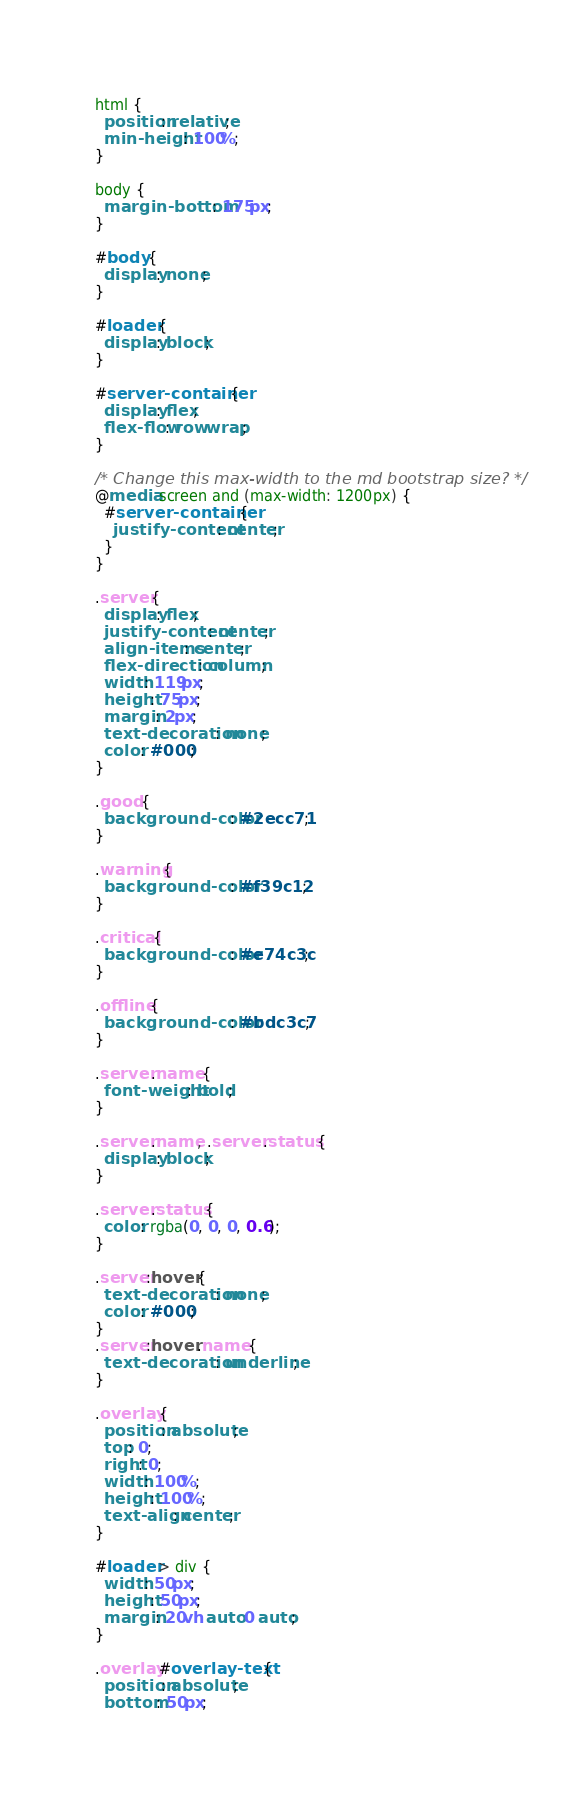Convert code to text. <code><loc_0><loc_0><loc_500><loc_500><_CSS_>html {
  position: relative;
  min-height: 100%;
}

body {
  margin-bottom: 175px;
}

#body {
  display: none;
}

#loader {
  display: block;
}

#server-container {
  display: flex;
  flex-flow: row wrap;
}

/* Change this max-width to the md bootstrap size? */
@media screen and (max-width: 1200px) {
  #server-container {
    justify-content: center;
  }
}

.server {
  display: flex;
  justify-content: center;
  align-items: center;
  flex-direction: column;
  width: 119px;
  height: 75px;
  margin: 2px;
  text-decoration: none;
  color: #000;
}

.good {
  background-color: #2ecc71;
}

.warning {
  background-color: #f39c12;
}

.critical {
  background-color: #e74c3c;
}

.offline {
  background-color: #bdc3c7;
}

.server .name {
  font-weight: bold;
}

.server .name, .server .status {
  display: block;
}

.server .status {
  color: rgba(0, 0, 0, 0.6);
}

.server:hover {
  text-decoration: none;
  color: #000;
}
.server:hover .name {
  text-decoration: underline;
}

.overlay {
  position: absolute;
  top: 0;
  right: 0;
  width: 100%;
  height: 100%;
  text-align: center;
}

#loader > div {
  width: 50px;
  height: 50px;
  margin: 20vh auto 0 auto;
}

.overlay #overlay-text {
  position: absolute;
  bottom: 50px;</code> 